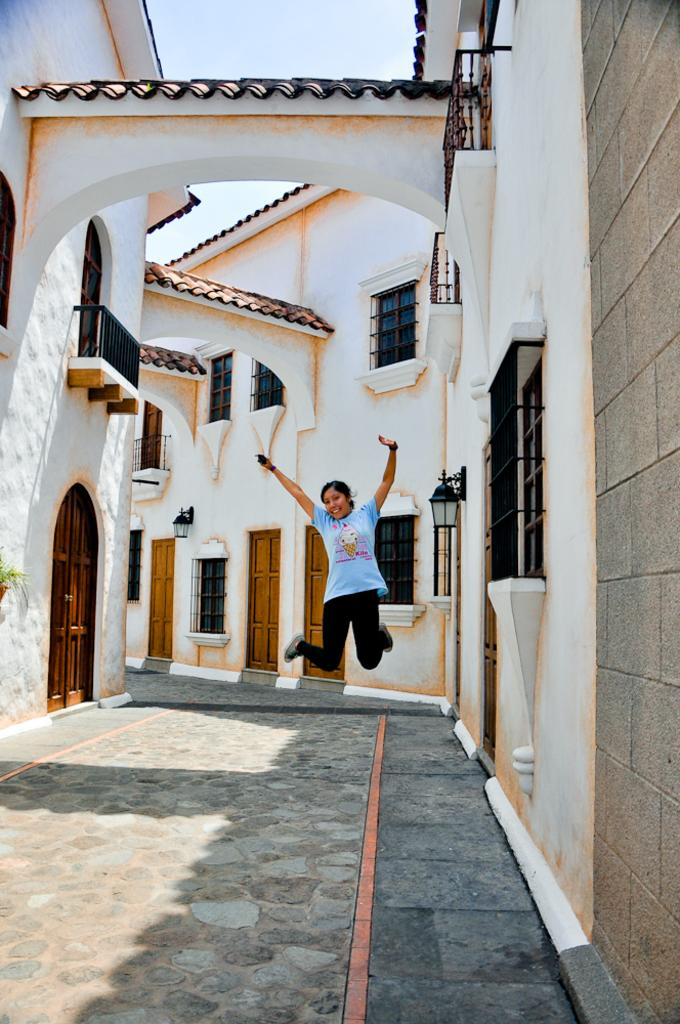Who is the main subject in the image? There is a woman in the center of the image. What is the woman wearing? The woman is wearing a dress. What can be seen in the background of the image? There is a building in the background of the image. Can you describe the building's features? The building has windows, railings, and lights. What is visible in the sky in the background of the image? The sky is visible in the background of the image. What type of rings does the carpenter wear while working on the building in the image? There is no carpenter present in the image, nor are there any rings visible. 